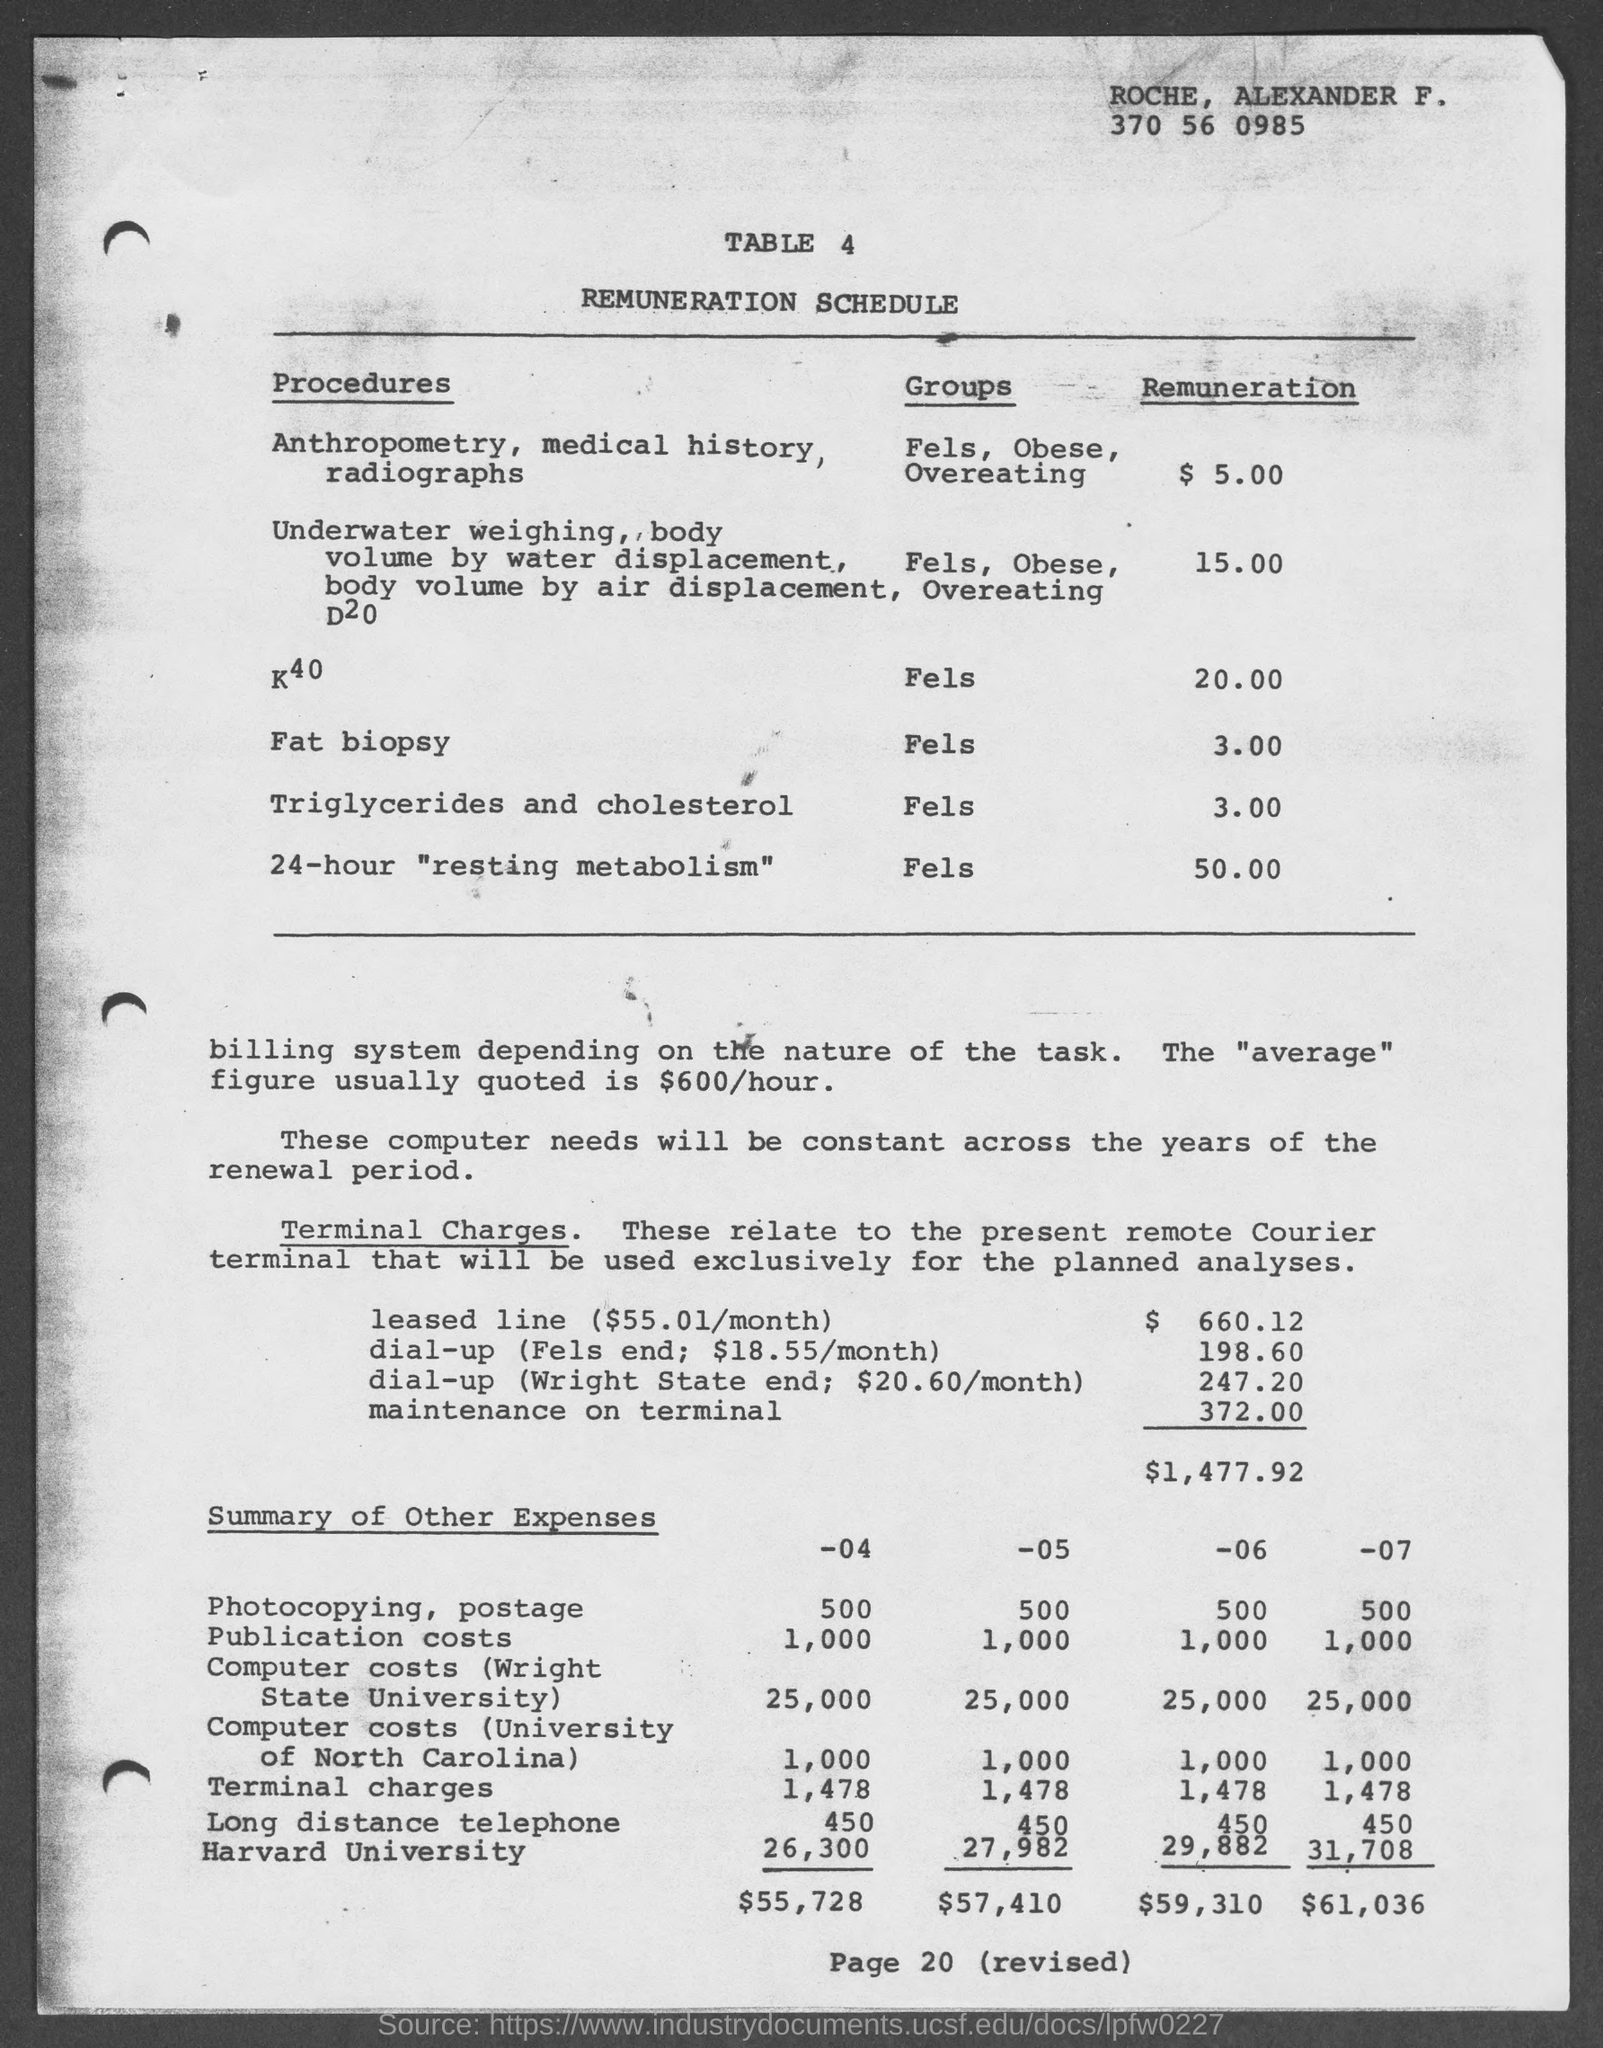What is the table no.?
Provide a succinct answer. 4. What is the title of table 4?
Ensure brevity in your answer.  Remuneration schedule. What is the page number at bottom of the page?
Provide a short and direct response. 20. 